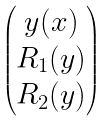Convert formula to latex. <formula><loc_0><loc_0><loc_500><loc_500>\begin{pmatrix} y ( x ) \\ R _ { 1 } ( y ) \\ R _ { 2 } ( y ) \end{pmatrix}</formula> 